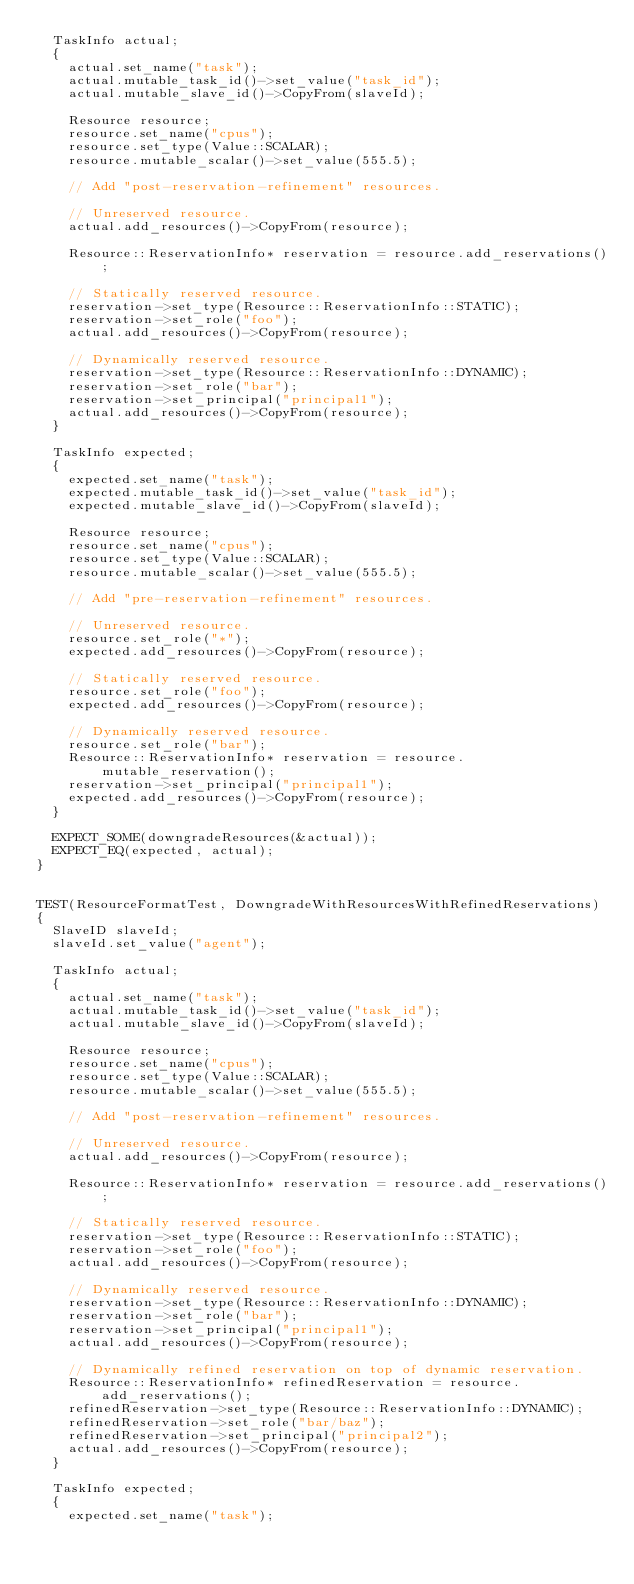Convert code to text. <code><loc_0><loc_0><loc_500><loc_500><_C++_>  TaskInfo actual;
  {
    actual.set_name("task");
    actual.mutable_task_id()->set_value("task_id");
    actual.mutable_slave_id()->CopyFrom(slaveId);

    Resource resource;
    resource.set_name("cpus");
    resource.set_type(Value::SCALAR);
    resource.mutable_scalar()->set_value(555.5);

    // Add "post-reservation-refinement" resources.

    // Unreserved resource.
    actual.add_resources()->CopyFrom(resource);

    Resource::ReservationInfo* reservation = resource.add_reservations();

    // Statically reserved resource.
    reservation->set_type(Resource::ReservationInfo::STATIC);
    reservation->set_role("foo");
    actual.add_resources()->CopyFrom(resource);

    // Dynamically reserved resource.
    reservation->set_type(Resource::ReservationInfo::DYNAMIC);
    reservation->set_role("bar");
    reservation->set_principal("principal1");
    actual.add_resources()->CopyFrom(resource);
  }

  TaskInfo expected;
  {
    expected.set_name("task");
    expected.mutable_task_id()->set_value("task_id");
    expected.mutable_slave_id()->CopyFrom(slaveId);

    Resource resource;
    resource.set_name("cpus");
    resource.set_type(Value::SCALAR);
    resource.mutable_scalar()->set_value(555.5);

    // Add "pre-reservation-refinement" resources.

    // Unreserved resource.
    resource.set_role("*");
    expected.add_resources()->CopyFrom(resource);

    // Statically reserved resource.
    resource.set_role("foo");
    expected.add_resources()->CopyFrom(resource);

    // Dynamically reserved resource.
    resource.set_role("bar");
    Resource::ReservationInfo* reservation = resource.mutable_reservation();
    reservation->set_principal("principal1");
    expected.add_resources()->CopyFrom(resource);
  }

  EXPECT_SOME(downgradeResources(&actual));
  EXPECT_EQ(expected, actual);
}


TEST(ResourceFormatTest, DowngradeWithResourcesWithRefinedReservations)
{
  SlaveID slaveId;
  slaveId.set_value("agent");

  TaskInfo actual;
  {
    actual.set_name("task");
    actual.mutable_task_id()->set_value("task_id");
    actual.mutable_slave_id()->CopyFrom(slaveId);

    Resource resource;
    resource.set_name("cpus");
    resource.set_type(Value::SCALAR);
    resource.mutable_scalar()->set_value(555.5);

    // Add "post-reservation-refinement" resources.

    // Unreserved resource.
    actual.add_resources()->CopyFrom(resource);

    Resource::ReservationInfo* reservation = resource.add_reservations();

    // Statically reserved resource.
    reservation->set_type(Resource::ReservationInfo::STATIC);
    reservation->set_role("foo");
    actual.add_resources()->CopyFrom(resource);

    // Dynamically reserved resource.
    reservation->set_type(Resource::ReservationInfo::DYNAMIC);
    reservation->set_role("bar");
    reservation->set_principal("principal1");
    actual.add_resources()->CopyFrom(resource);

    // Dynamically refined reservation on top of dynamic reservation.
    Resource::ReservationInfo* refinedReservation = resource.add_reservations();
    refinedReservation->set_type(Resource::ReservationInfo::DYNAMIC);
    refinedReservation->set_role("bar/baz");
    refinedReservation->set_principal("principal2");
    actual.add_resources()->CopyFrom(resource);
  }

  TaskInfo expected;
  {
    expected.set_name("task");</code> 